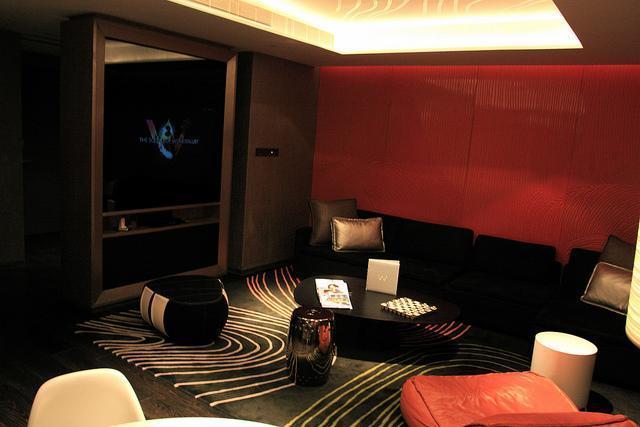How many chairs are there?
Give a very brief answer. 2. 